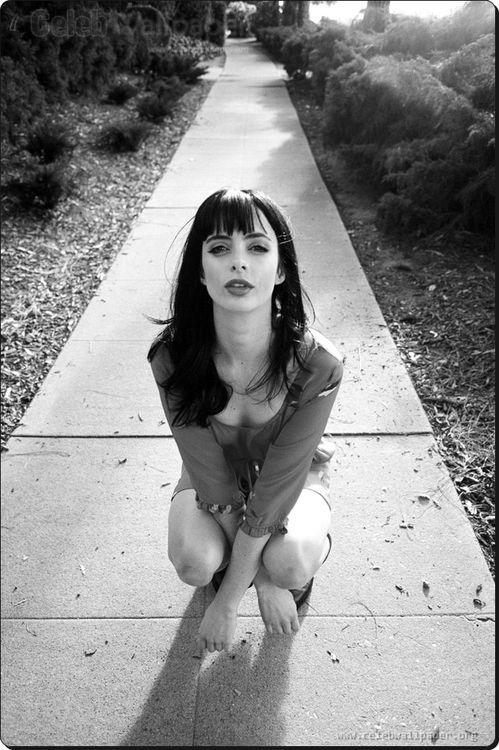If this were a scene depicting a superpower moment, what power is being revealed? In this scene, the moment is charged with the revelation of Eliza's extraordinary psychic abilities. As she kneels on the sidewalk, her intense focus signifies her harnessing the power of telekinesis. The surrounding area quivers, leaves and small debris rising gently around her, hinting at the immense energy she is channeling. Eliza is preparing to use her powers to uncover hidden truths and protect herself from impending danger. 